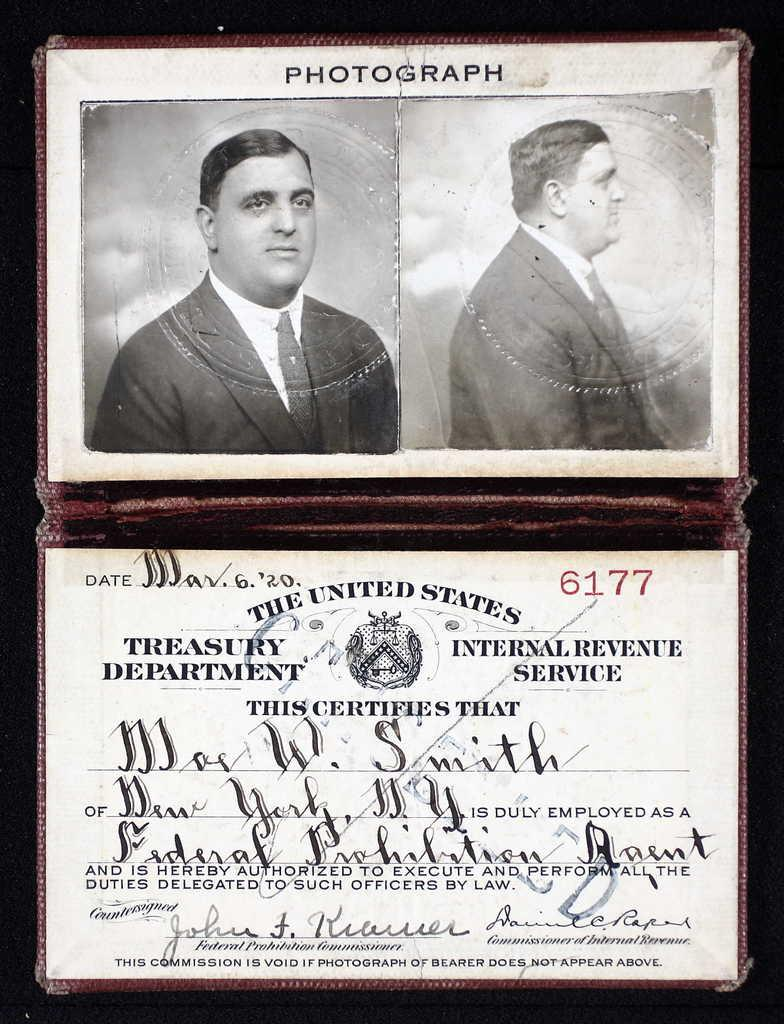What type of items are visible in the image? There are photographs of a person and a card with printed text in the image. Where are the photographs located in the image? The photographs are at the top of the image. Where is the card located in the image? The card is at the bottom of the image. How are the photographs and card arranged in the image? The photographs and card are kept in a wallet. What type of string is used to hold the photographs together in the image? There is no string visible in the image; the photographs and card are kept in a wallet. What kind of noise can be heard coming from the photographs in the image? There is no noise associated with the photographs in the image; they are still images. 